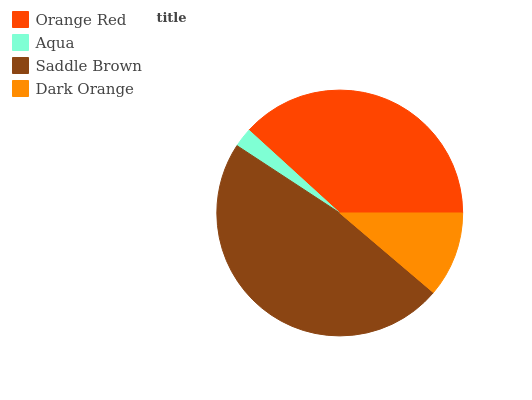Is Aqua the minimum?
Answer yes or no. Yes. Is Saddle Brown the maximum?
Answer yes or no. Yes. Is Saddle Brown the minimum?
Answer yes or no. No. Is Aqua the maximum?
Answer yes or no. No. Is Saddle Brown greater than Aqua?
Answer yes or no. Yes. Is Aqua less than Saddle Brown?
Answer yes or no. Yes. Is Aqua greater than Saddle Brown?
Answer yes or no. No. Is Saddle Brown less than Aqua?
Answer yes or no. No. Is Orange Red the high median?
Answer yes or no. Yes. Is Dark Orange the low median?
Answer yes or no. Yes. Is Dark Orange the high median?
Answer yes or no. No. Is Aqua the low median?
Answer yes or no. No. 